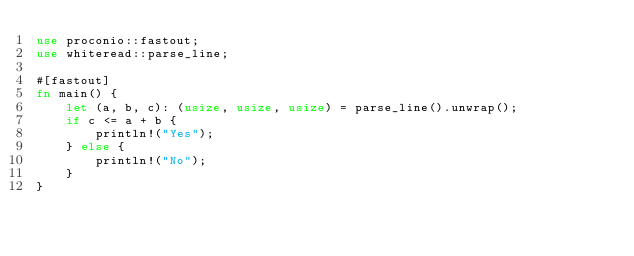Convert code to text. <code><loc_0><loc_0><loc_500><loc_500><_Rust_>use proconio::fastout;
use whiteread::parse_line;

#[fastout]
fn main() {
    let (a, b, c): (usize, usize, usize) = parse_line().unwrap();
    if c <= a + b {
        println!("Yes");
    } else {
        println!("No");
    }
}
</code> 